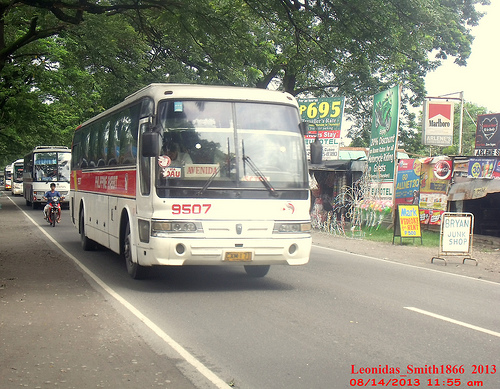Please provide the bounding box coordinate of the region this sentence describes: windshield on a white bus. The bounding box coordinate for the windshield on a white bus is [0.31, 0.3, 0.62, 0.51]. 